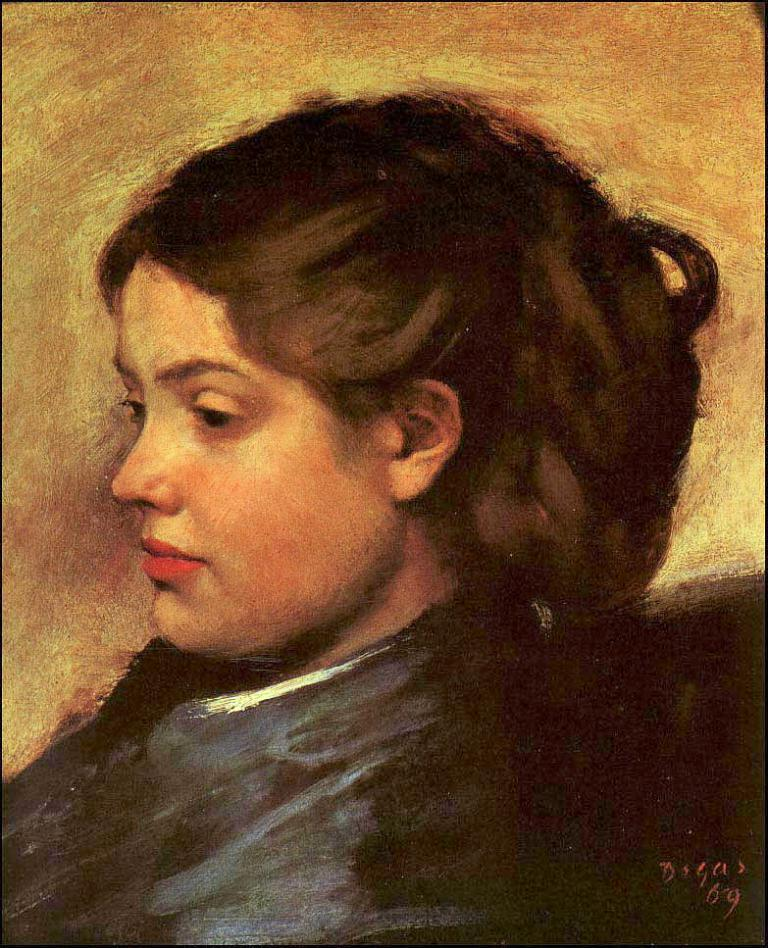What is the main subject of the painting in the image? There is a painting of a woman in the image. Can you hear the woman in the painting laughing in the image? There is no sound in the image, and the woman in the painting is not laughing. Additionally, the woman in the painting is not a real person, so she cannot produce sound. 